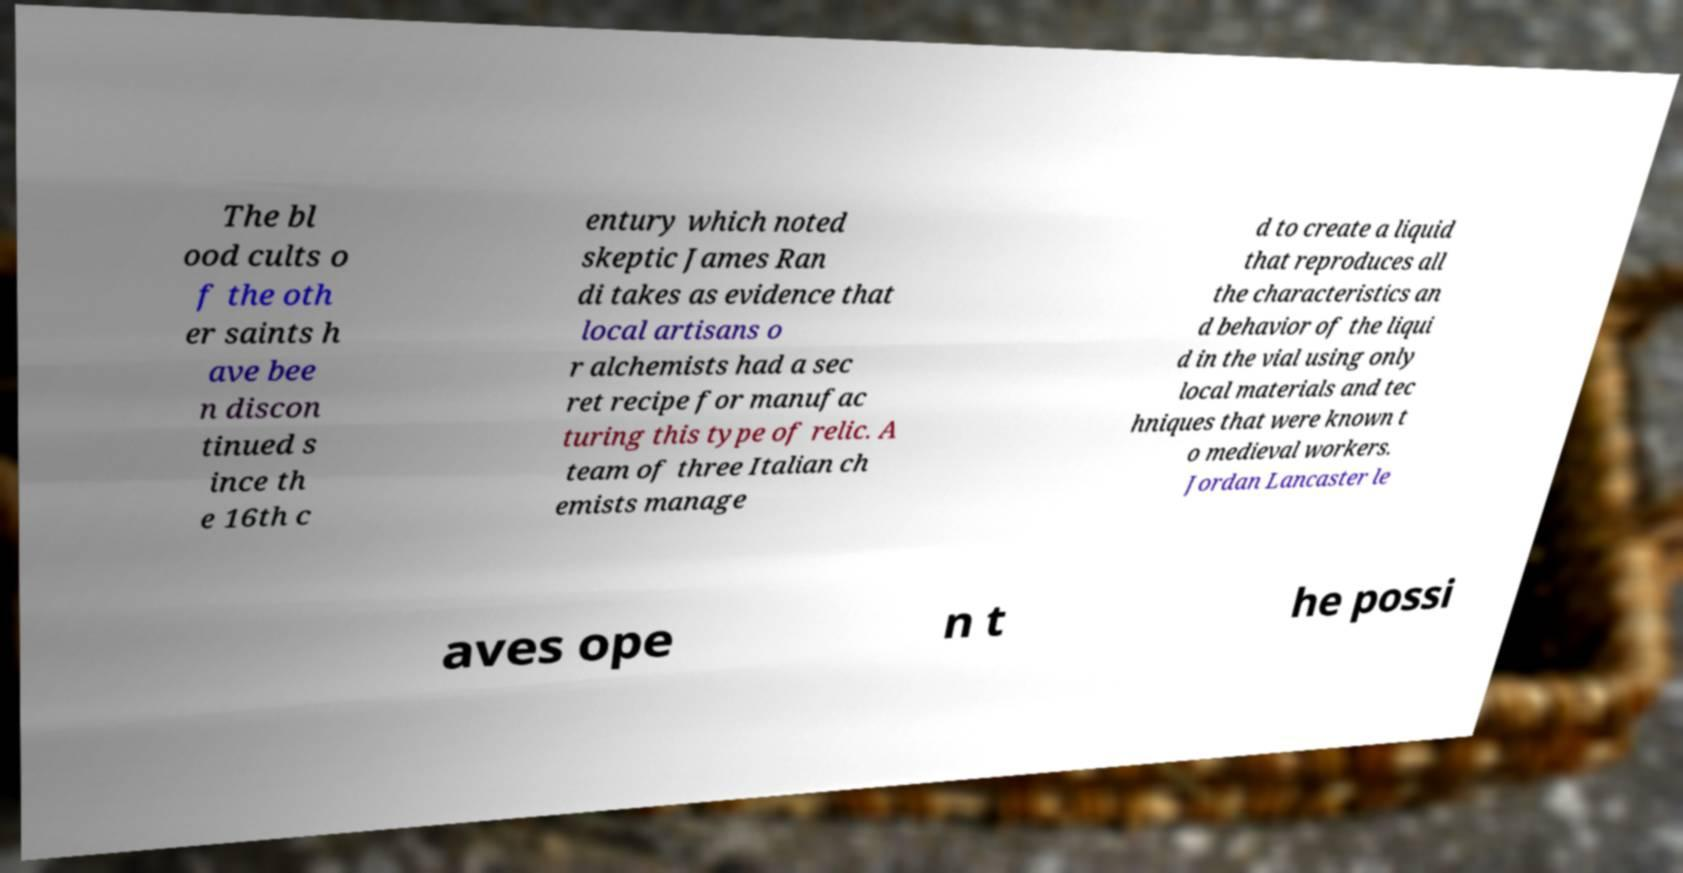Could you extract and type out the text from this image? The bl ood cults o f the oth er saints h ave bee n discon tinued s ince th e 16th c entury which noted skeptic James Ran di takes as evidence that local artisans o r alchemists had a sec ret recipe for manufac turing this type of relic. A team of three Italian ch emists manage d to create a liquid that reproduces all the characteristics an d behavior of the liqui d in the vial using only local materials and tec hniques that were known t o medieval workers. Jordan Lancaster le aves ope n t he possi 